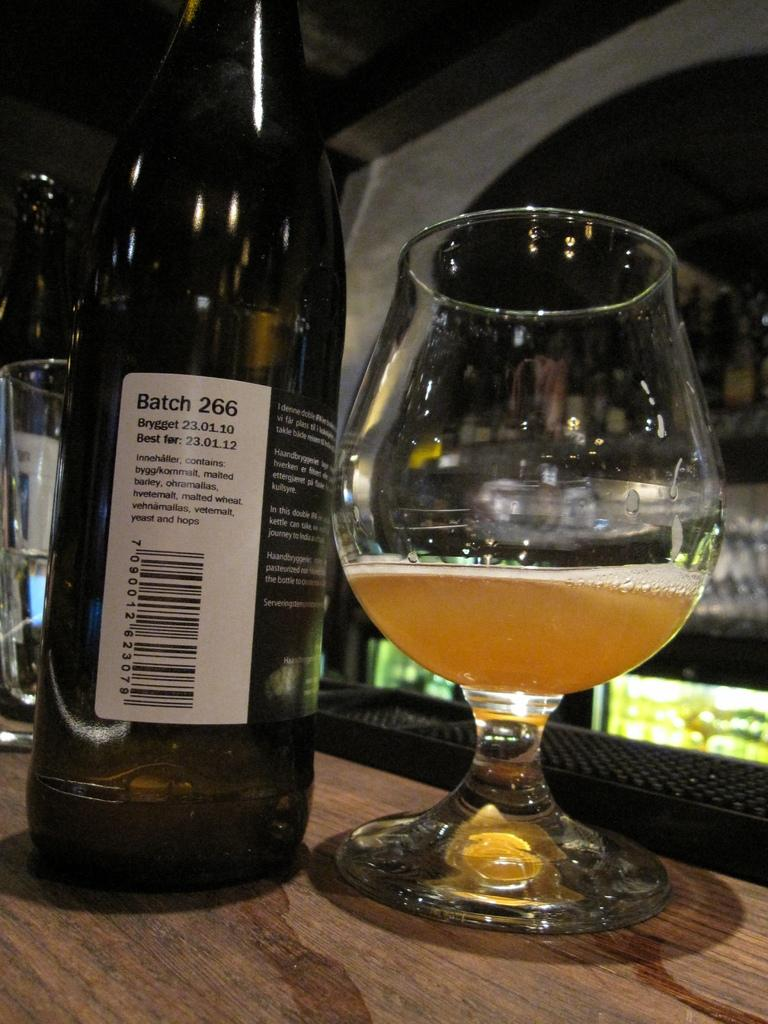What objects are on the wooden surface in the image? There are bottles and glasses on the wooden surface. Can you describe the contents of the glasses? There is a liquid in at least one of the glasses. Where is the flock of birds resting in the image? There are no birds or flocks present in the image. What type of popcorn is being served in the glasses? The glasses contain a liquid, not popcorn, so there is no popcorn in the image. 